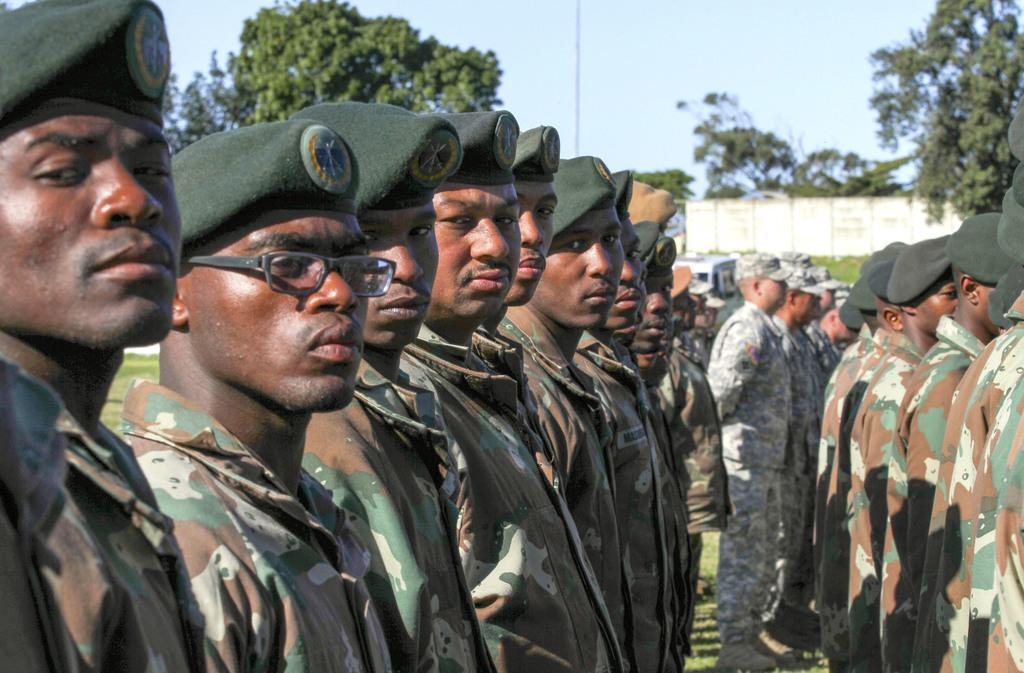What are the people in the image doing? The people are standing in a row in the center of the image. What are the people wearing? The people are wearing uniforms. What can be seen in the background of the image? There are trees, a wall, and the sky visible in the background of the image. How many cows are present in the image? There are no cows present in the image. What type of coach is standing next to the people in the image? There is no coach present in the image; only people wearing uniforms are visible. 